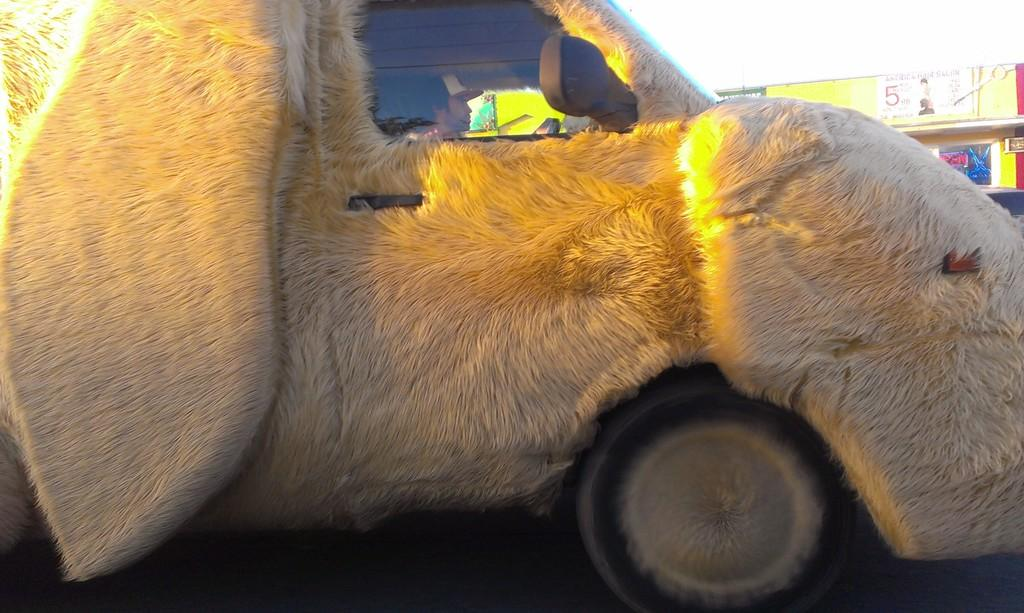What is the main subject in the center of the image? There is a car in the center of the image. Who or what is inside the car? A person is sitting inside the car. What can be seen in the background of the image? There are banners with text in the background of the image. How would you describe the weather based on the image? The sky is cloudy in the image, suggesting a potentially overcast or cloudy day. What type of stem can be seen growing from the ground in the image? There is no stem or plant visible in the image; it primarily features a car, a person, banners, and a cloudy sky. 